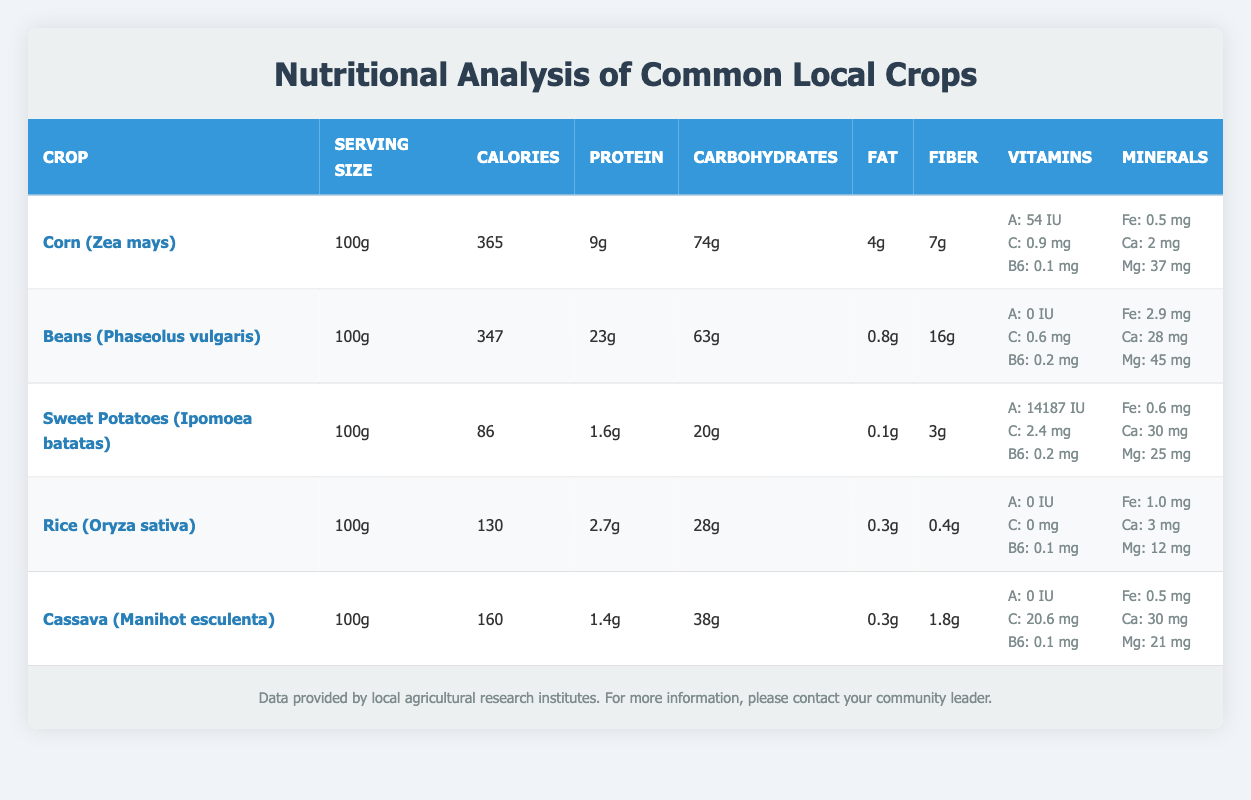What is the serving size for all the crops listed? All the crops listed in the table have a serving size of 100g. This is consistent across the table, allowing for direct comparisons of their nutritional content on the same basis.
Answer: 100g Which crop has the highest protein content per 100g? Looking at the protein column, Beans (Phaseolus vulgaris) has the highest protein content at 23g per 100g, when compared to the others: Corn has 9g, Sweet Potatoes has 1.6g, Rice has 2.7g, and Cassava has 1.4g.
Answer: Beans (Phaseolus vulgaris) What is the total amount of carbohydrates in Sweet Potatoes and Cassava combined? The carbohydrates in Sweet Potatoes is 20g, and in Cassava it is 38g. Adding these two together: 20g + 38g = 58g.
Answer: 58g Is the vitamin C content in Corn higher than in Sweet Potatoes? Corn has 0.9 mg of Vitamin C while Sweet Potatoes has 2.4 mg. Comparing these values, Sweet Potatoes has higher Vitamin C content than Corn.
Answer: No Which crop has the least amount of fat per 100g? By examining the fat column, we see that Sweet Potatoes has 0.1g of fat, which is the lowest compared to the other crops listed: Corn has 4g, Beans has 0.8g, Rice has 0.3g, and Cassava has 0.3g.
Answer: Sweet Potatoes What is the average amount of Iron in all the crops listed? The Iron content for each crop is: Corn 0.5 mg, Beans 2.9 mg, Sweet Potatoes 0.6 mg, Rice 1.0 mg, and Cassava 0.5 mg. To find the average, sum these amounts: 0.5 + 2.9 + 0.6 + 1.0 + 0.5 = 5.5 mg. Divide by the number of crops (5): 5.5 / 5 = 1.1 mg.
Answer: 1.1 mg Which crop has the highest calorie count? Checking the calories column, Corn (Zea mays) has the highest calorie count at 365 calories per 100g, higher than Beans at 347, Sweet Potatoes at 86, Rice at 130, and Cassava at 160.
Answer: Corn (Zea mays) Are all crops listed a good source of Vitamin A? Corn has 54 IU, Beans has 0 IU, Sweet Potatoes has 14187 IU, Rice has 0 IU, and Cassava has 0 IU. Given that Sweet Potatoes contains a very high amount, while others have none, we conclude only Sweet Potatoes is a significant source of Vitamin A.
Answer: No 